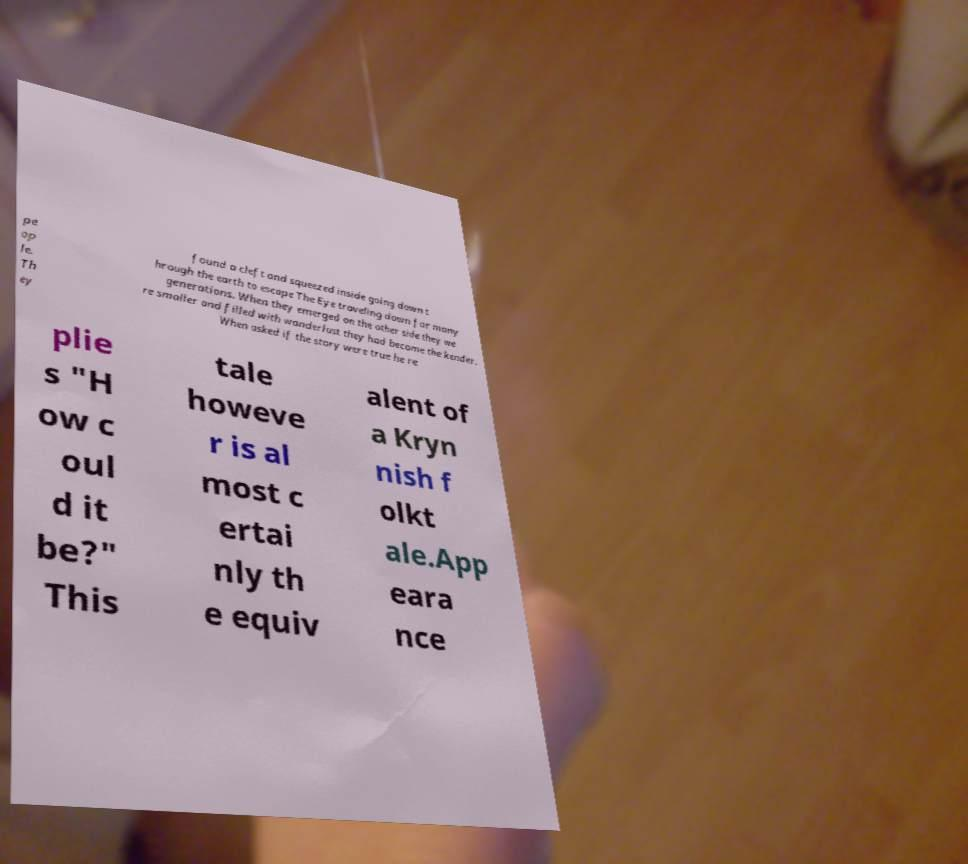Could you extract and type out the text from this image? pe op le. Th ey found a cleft and squeezed inside going down t hrough the earth to escape The Eye traveling down for many generations. When they emerged on the other side they we re smaller and filled with wanderlust they had become the kender. When asked if the story were true he re plie s "H ow c oul d it be?" This tale howeve r is al most c ertai nly th e equiv alent of a Kryn nish f olkt ale.App eara nce 